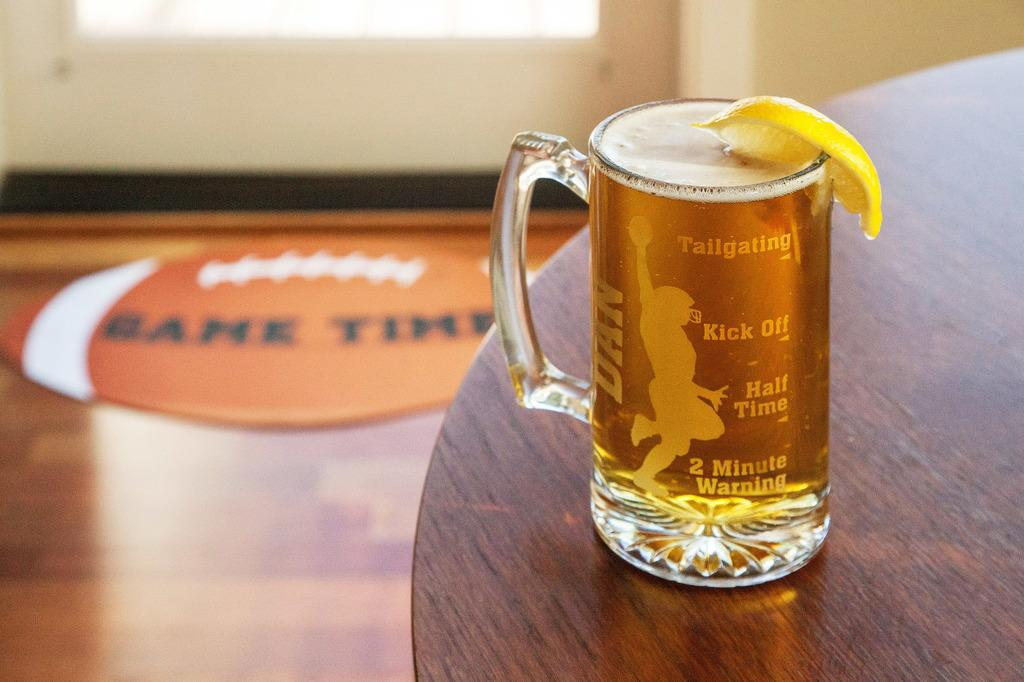What is placed on the table in the image? There is a glass on the table in the image. What is inside the glass? There is a drink in the glass. What is the color of the table? The table is brown. What is on the floor in the image? There is a mat placed on the floor. What can be seen in the background of the image? There is a wall in the background of the image. What is the mother writing on the wall in the image? There is no mother or writing on the wall in the image. 